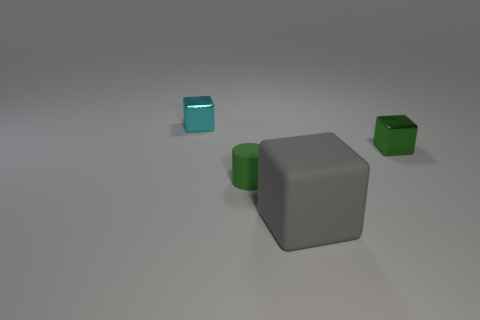How does the lighting in the scene affect the color appearance of the objects? The lighting in this scene casts diffuse shadows and provides a soft illumination that slightly affects the perception of color, without drastically altering it. It creates a uniform ambiance ensuring that the true colors of the objects are discernible. 